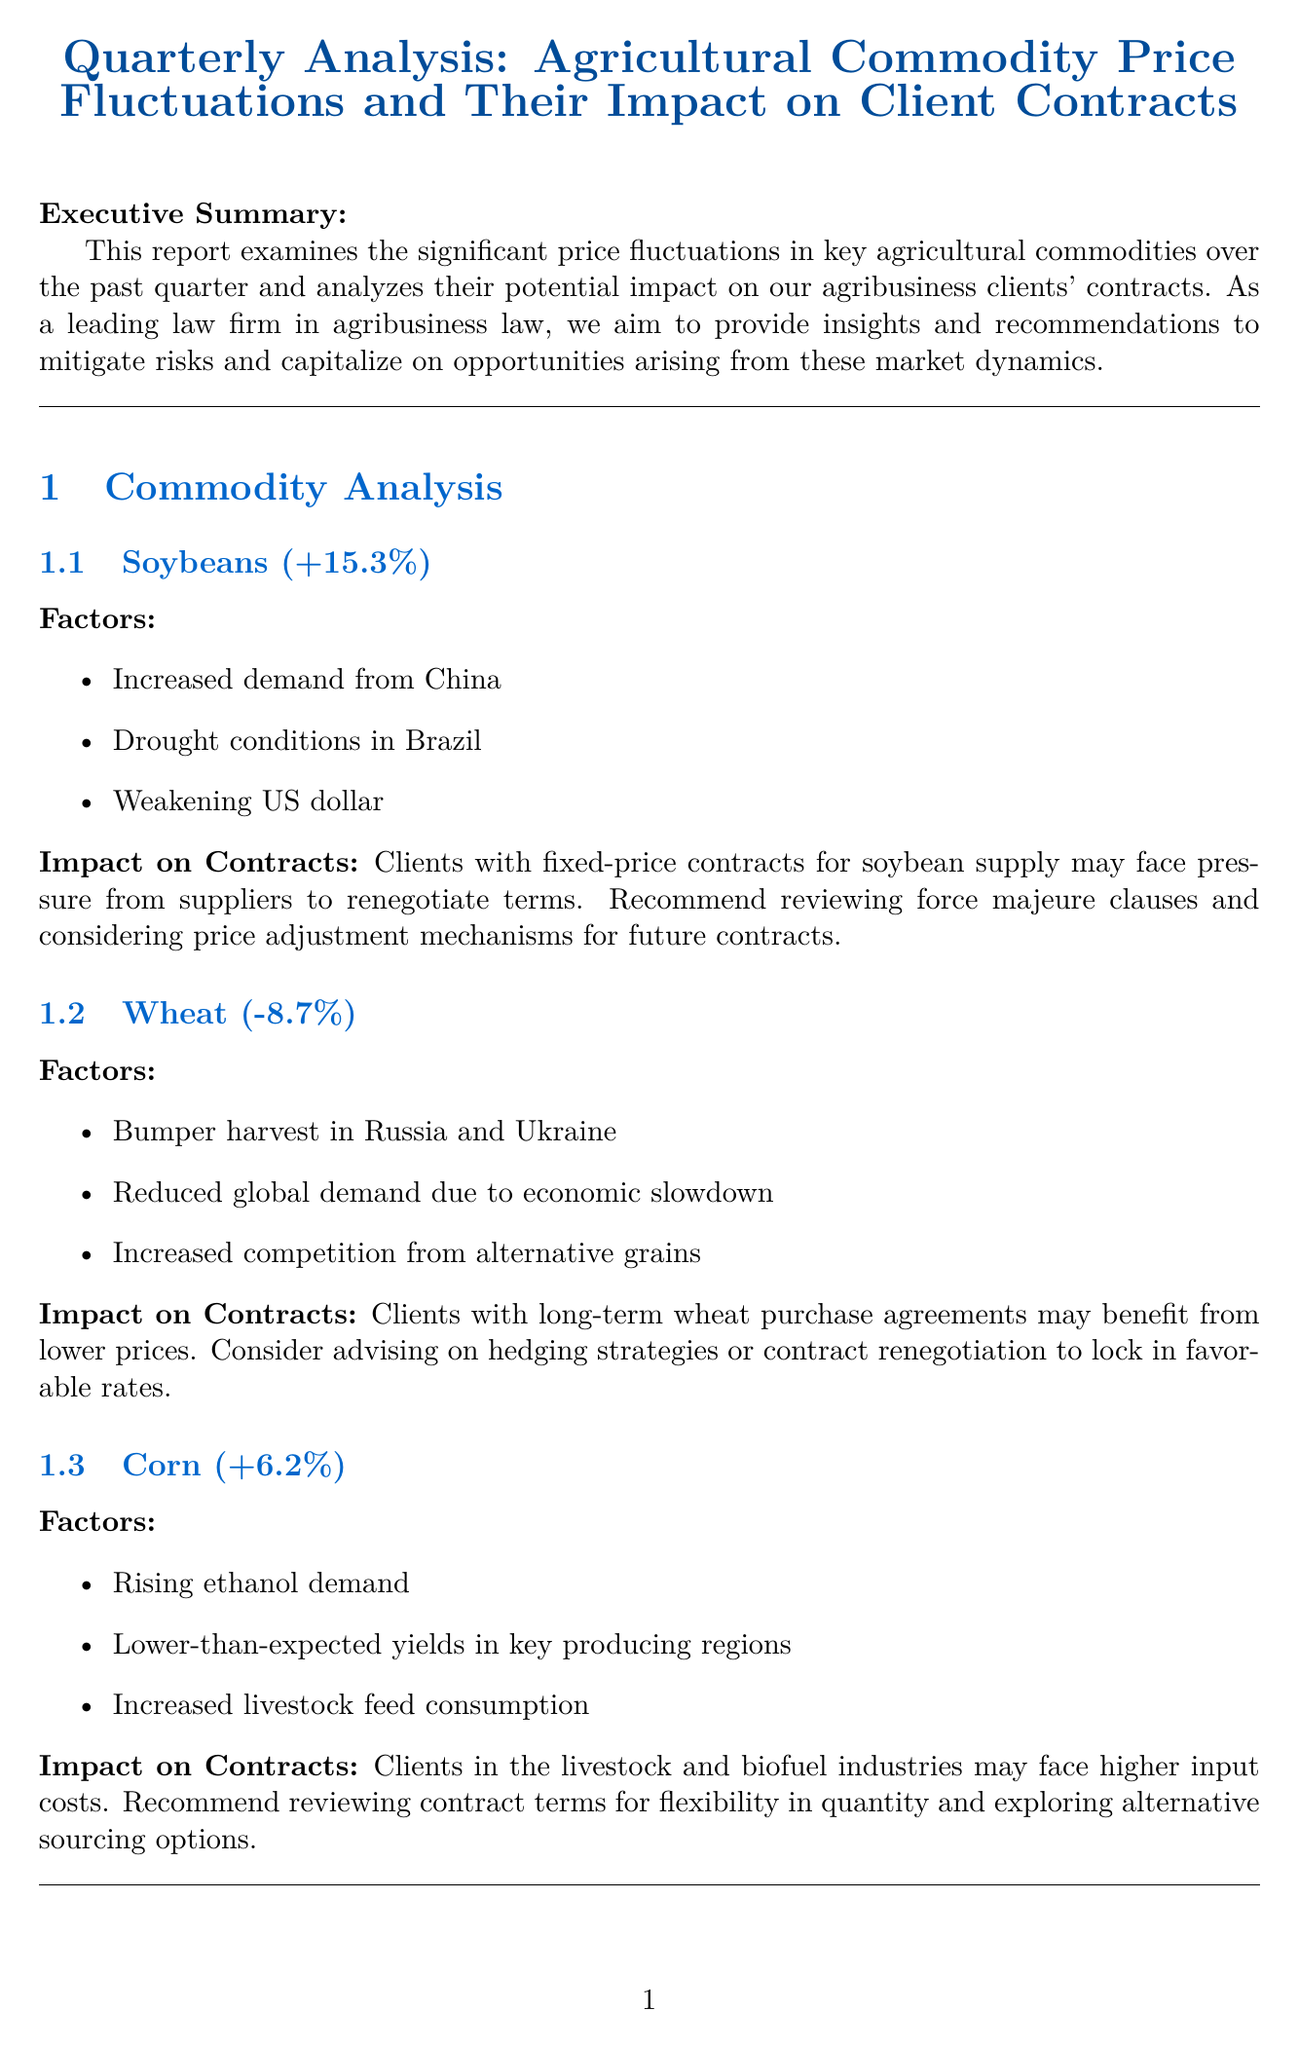What is the title of the report? The title is stated at the beginning of the document as the subject of the analysis.
Answer: Quarterly Analysis: Agricultural Commodity Price Fluctuations and Their Impact on Client Contracts What percentage did soybean prices change? This information is listed under the commodity analysis section for soybeans.
Answer: +15.3% What are the factors affecting wheat prices? These factors are detailed in the commodity analysis section for wheat.
Answer: Bumper harvest in Russia and Ukraine, Reduced global demand due to economic slowdown, Increased competition from alternative grains What legal issue is related to force majeure clauses? The document discusses this issue in the legal considerations section and highlights its relevance to contracts amidst price volatility.
Answer: Recent commodity price volatility may trigger force majeure clauses What is one recommendation for clients regarding existing contracts? Recommendations are provided in a specific section of the report, focusing on actions clients should consider in light of price fluctuations.
Answer: Conduct a comprehensive review of existing contracts to identify potential vulnerabilities to price fluctuations What was the solution for the Midwest Grain Processors Cooperative? This information is found in the case studies section regarding a specific client's situation.
Answer: Negotiated a hybrid pricing model incorporating both fixed and floating components What is the short-term market outlook mentioned in the report? This outlook is summarized in the market outlook section at the end of the report.
Answer: Expect continued volatility in grain markets due to geopolitical tensions and weather uncertainties How many authors contributed to the report? This detail can be found in the about the authors section where individual contributions are listed.
Answer: 2 